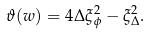<formula> <loc_0><loc_0><loc_500><loc_500>\vartheta ( w ) = 4 \Delta \xi _ { \phi } ^ { 2 } - \xi _ { \Delta } ^ { 2 } .</formula> 